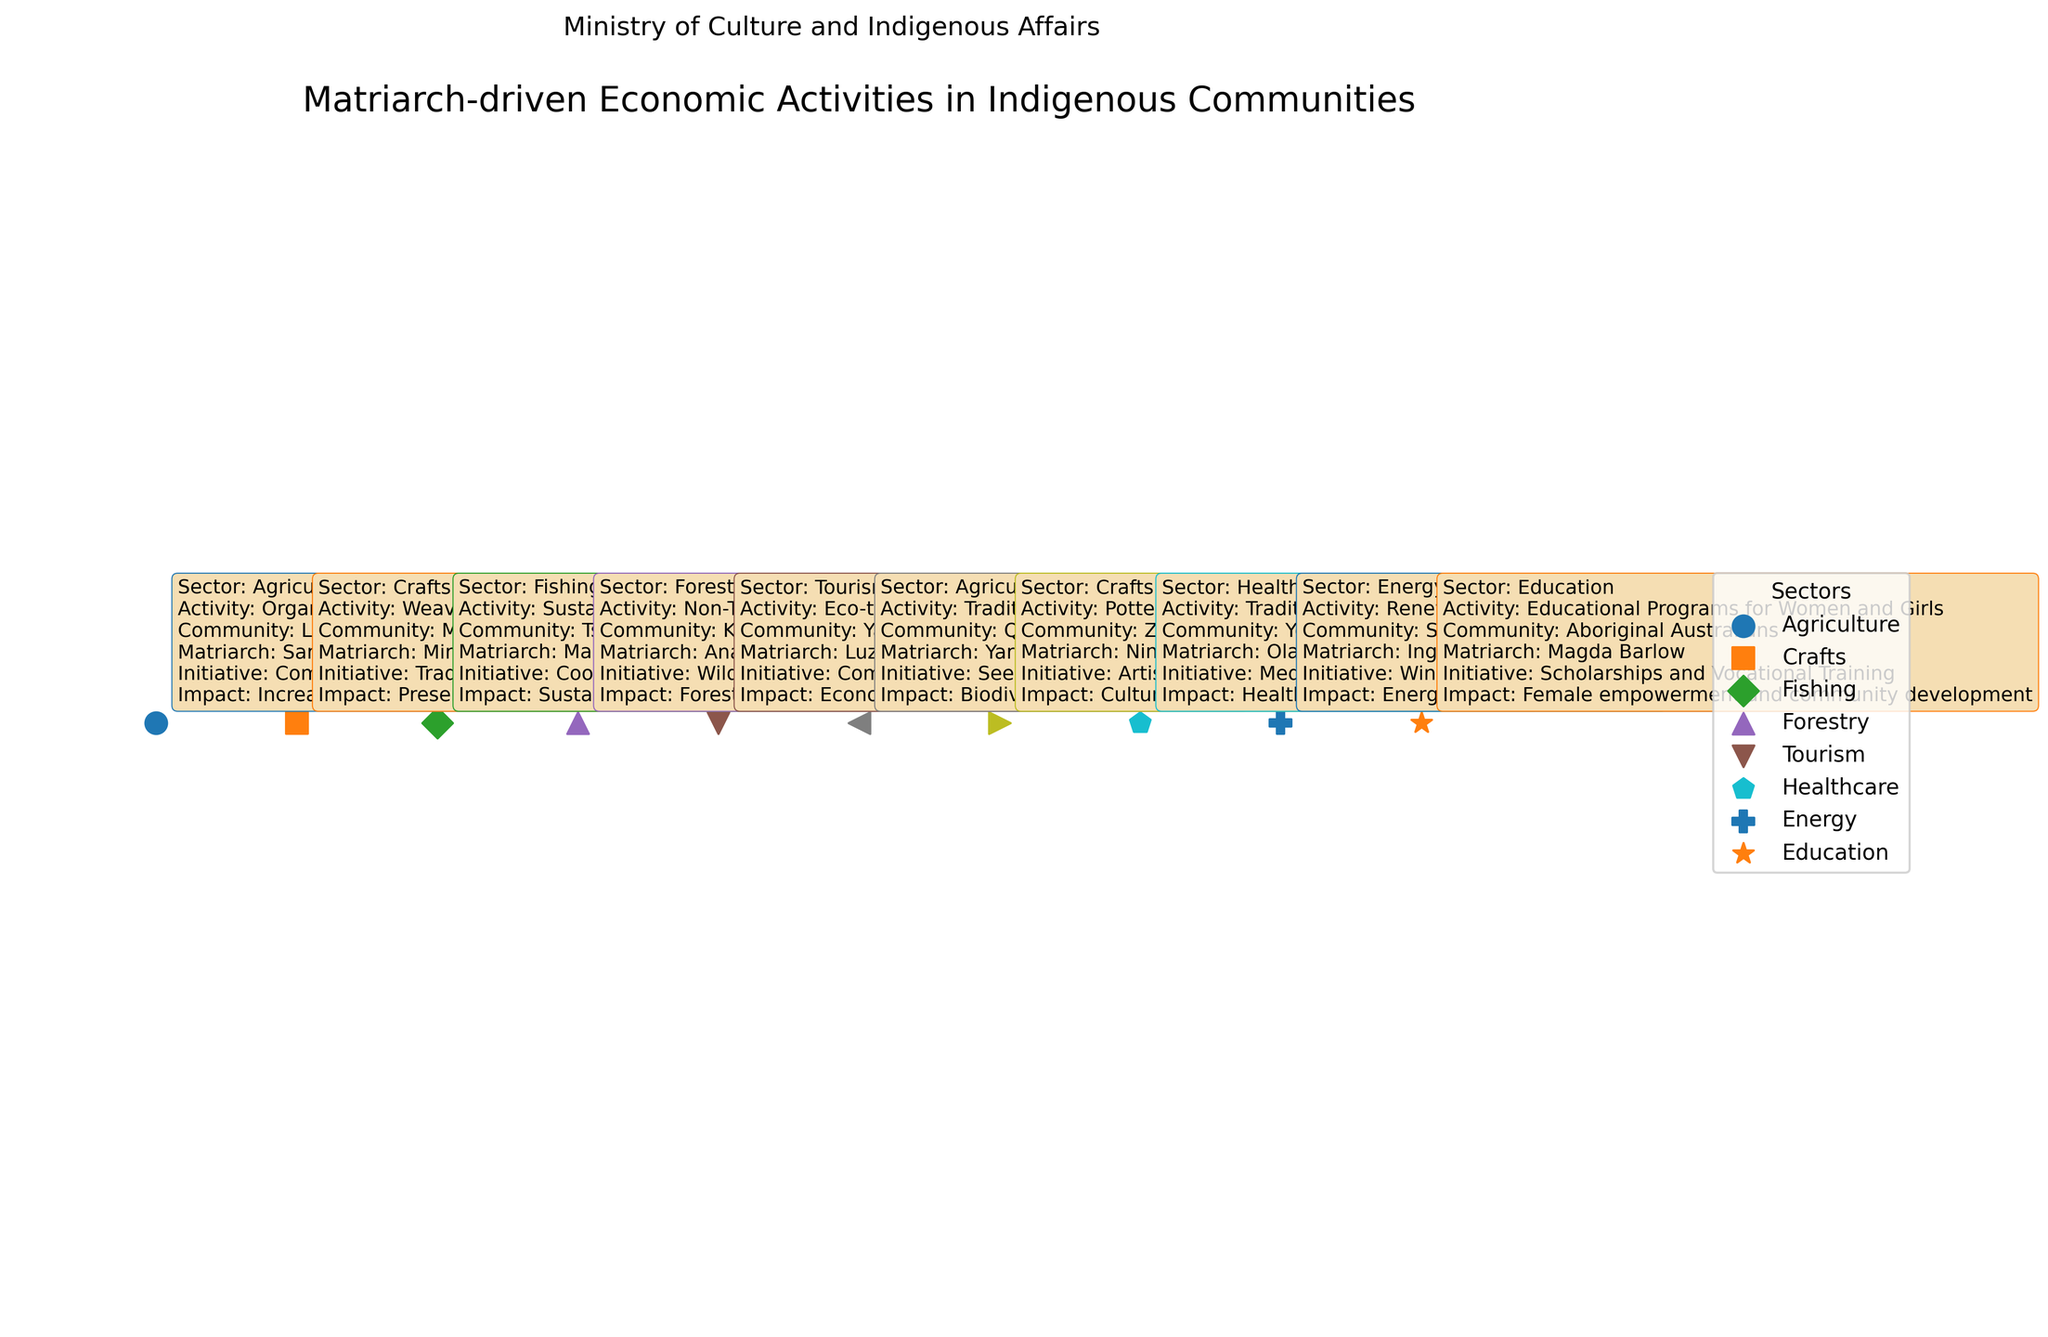Which sector has the initiative titled "Community Supported Agriculture"? Locate the section of the chart associated with the "Community Supported Agriculture" initiative and identify the sector it belongs to.
Answer: Agriculture What is the primary impact of the "Wind and Solar Energy Installations" initiative? Find the annotation related to "Wind and Solar Energy Installations" and read the impact description provided in the text.
Answer: Energy independence and sustainable growth How many sectors focus on preserving cultural heritage? Read through the activities and impacts in each annotated text and count how many initiatives mention the preservation of cultural heritage.
Answer: Three Which community is associated with the matriarch named Olayinka Adekoya? Locate the annotation listing Olayinka Adekoya as the matriarch and identify the associated community.
Answer: Yoruba Compare the initiatives between the sectors of Crafts and Agriculture. Which sector has more diverse initiatives in terms of different types of activities? Count the number of unique activities listed under the "Crafts" sector and do the same for the "Agriculture" sector, then compare the counts.
Answer: Agriculture What visual attribute distinguishes the activities within different sectors in the chart? Observe the graphical elements used in the chart, such as markers and colors, to identify how different sectors are visually distinguished.
Answer: Colors Which sector's initiative impacts both economic autonomy and sustainable resource use? Locate the initiatives with these dual impacts by reading through the annotations in each sector and identify the respective sector.
Answer: Fishing How many matriarchs are involved in the Agriculture sector? Identify all the annotations under the "Agriculture" sector and count the number of unique matriarch names listed.
Answer: Two Describe the initiative led by Luzia Silva. Find the annotation related to Luzia Silva and summarize the initiative details provided, including the specific activity, community, and primary impact.
Answer: Luzia Silva leads the "Community-managed Eco-lodges" initiative within the Yanomami community, focusing on economic growth with cultural preservation 